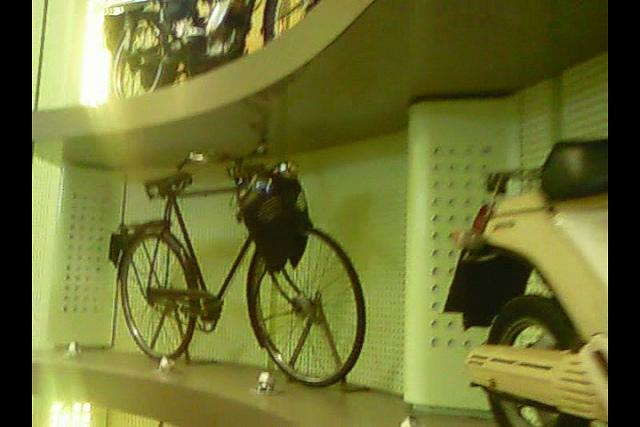What mode of transportation is featured?

Choices:
A) bike
B) car
C) bus
D) train bike 